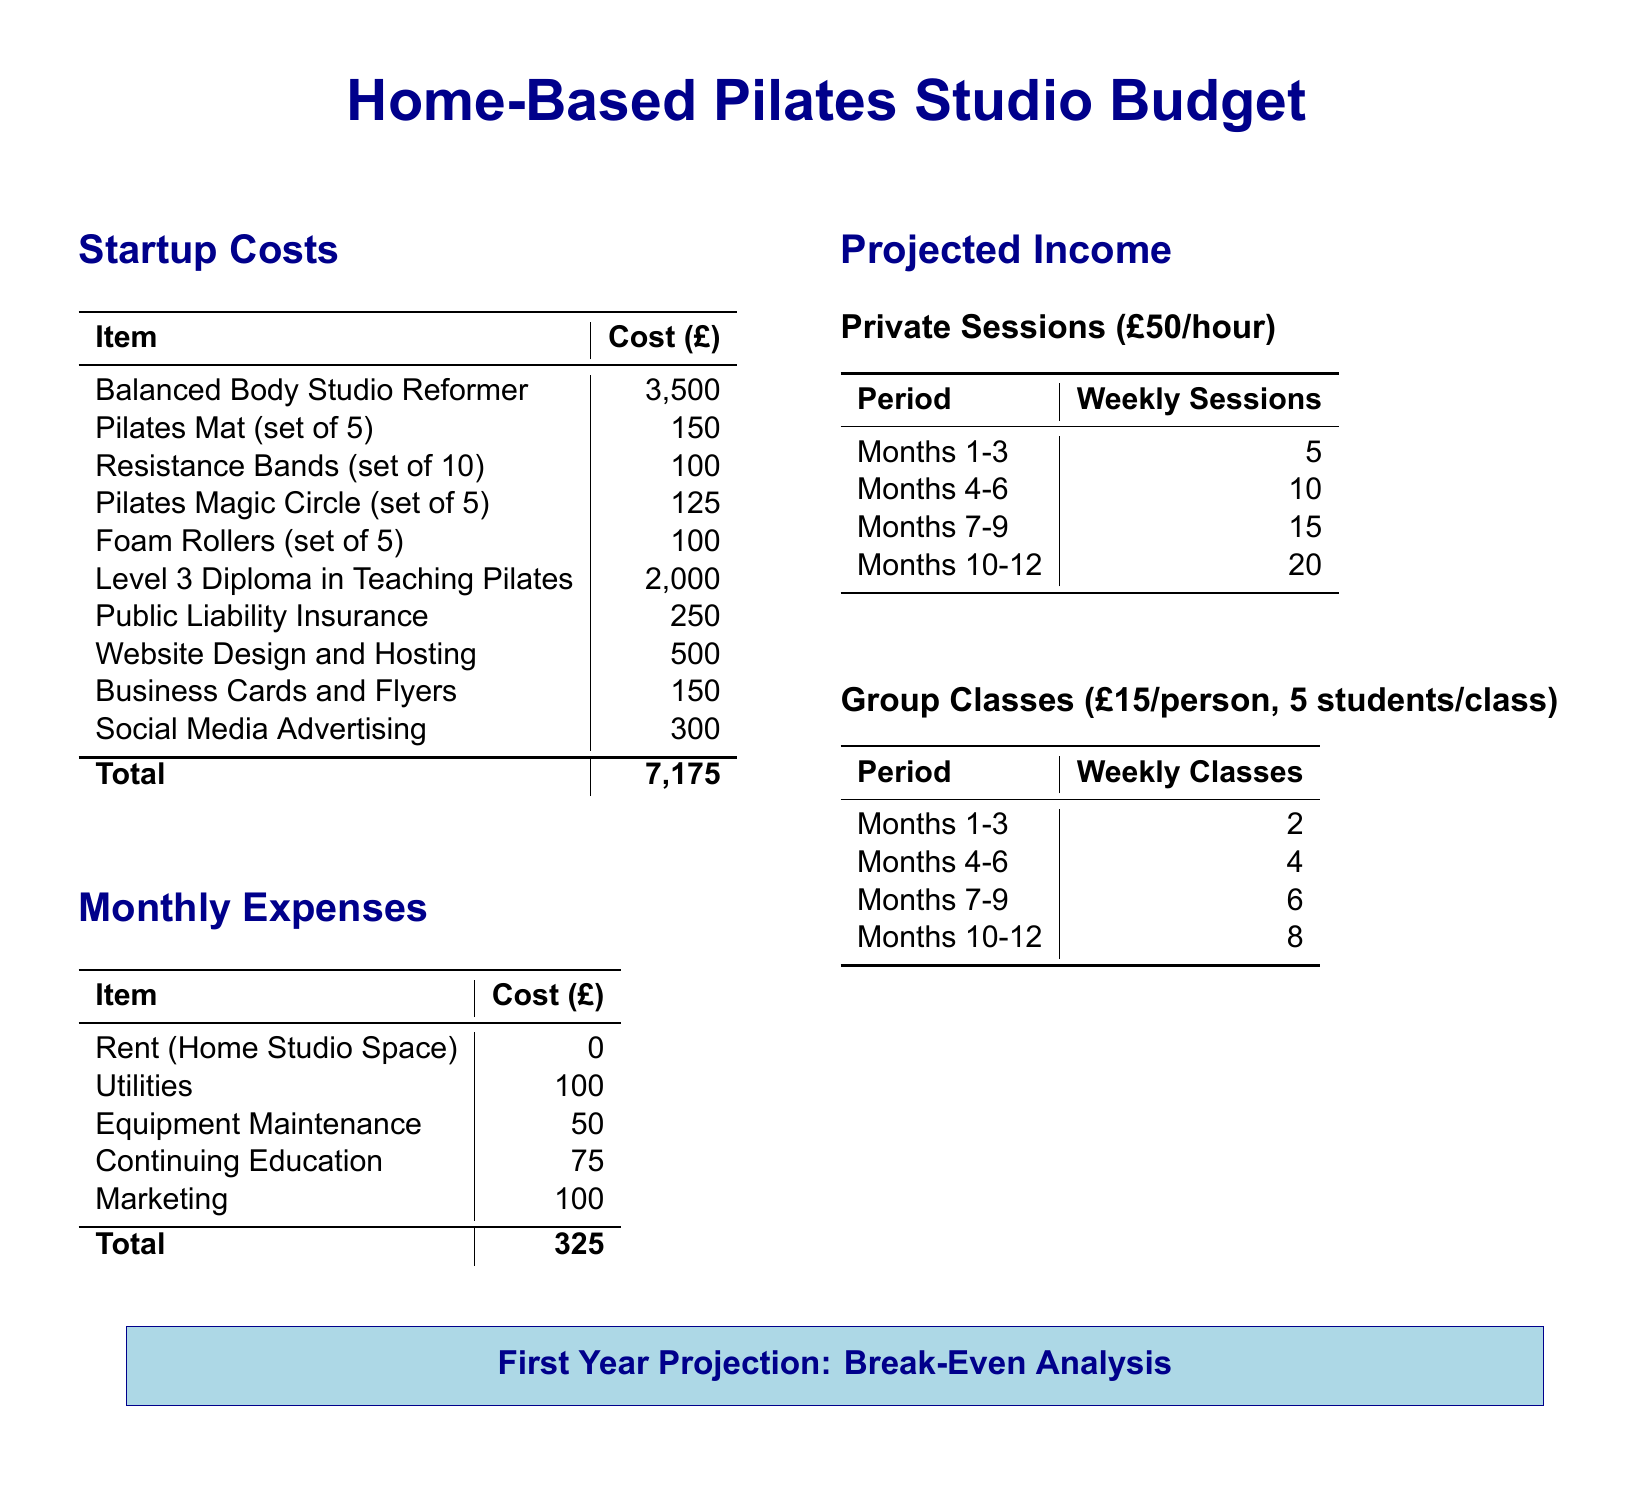what is the total startup cost? The total startup cost is listed at the bottom of the startup costs section.
Answer: 7,175 how much does a Balanced Body Studio Reformer cost? The cost of a Balanced Body Studio Reformer is specifically stated in the startup costs section.
Answer: 3,500 what is the monthly expense for utilities? The monthly expense for utilities is specified in the monthly expenses section.
Answer: 100 how many weekly private sessions are projected for months 4-6? The number of weekly private sessions for months 4-6 is detailed in the projected income section.
Answer: 10 what is the cost per person for group classes? The cost per person for group classes is mentioned in the projected income section.
Answer: 15 what is the total monthly expense? The total monthly expense is the sum of all monthly expenses listed in the document.
Answer: 325 how many group classes are planned per week in months 10-12? The number of group classes planned for months 10-12 is provided in the projected income section.
Answer: 8 what is the cost for public liability insurance? The cost for public liability insurance is clearly stated in the startup costs section.
Answer: 250 how much is set aside for marketing monthly? The monthly marketing expense is indicated in the monthly expenses section.
Answer: 100 